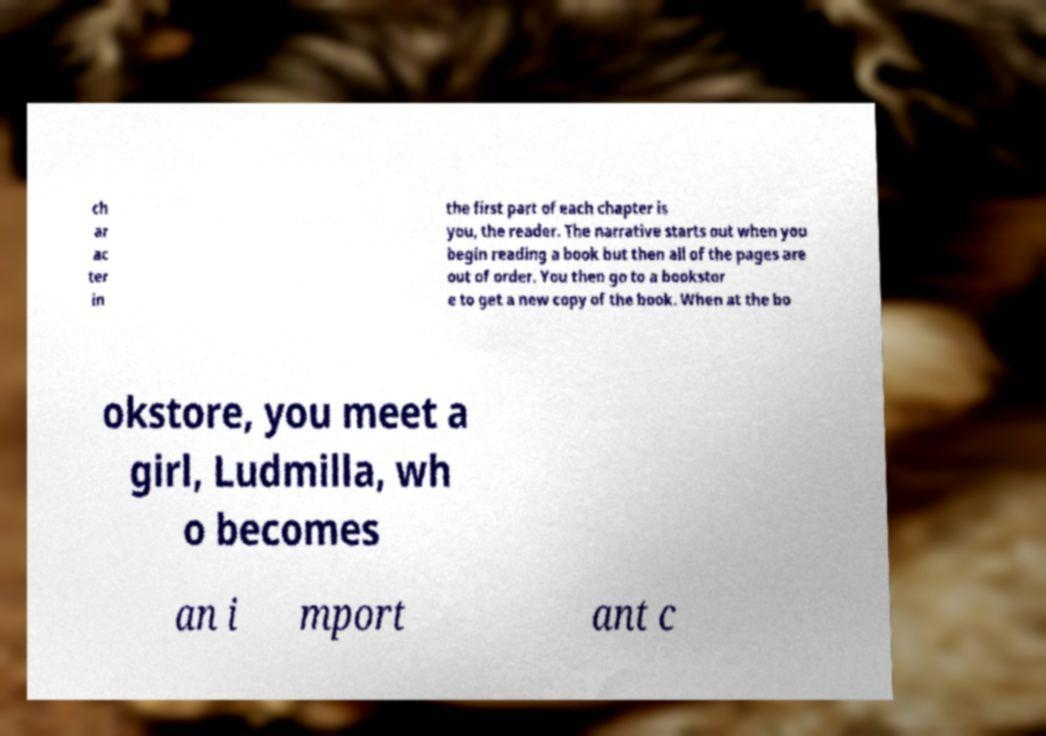I need the written content from this picture converted into text. Can you do that? ch ar ac ter in the first part of each chapter is you, the reader. The narrative starts out when you begin reading a book but then all of the pages are out of order. You then go to a bookstor e to get a new copy of the book. When at the bo okstore, you meet a girl, Ludmilla, wh o becomes an i mport ant c 